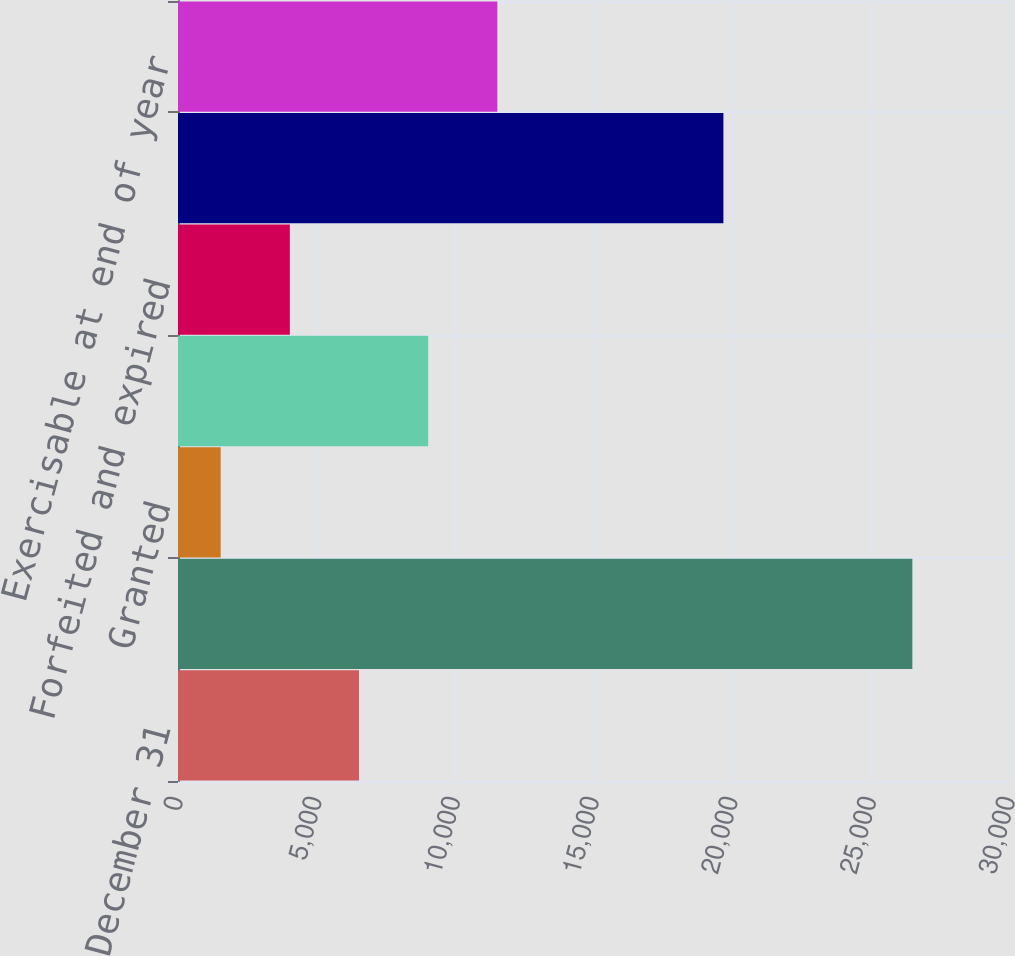Convert chart. <chart><loc_0><loc_0><loc_500><loc_500><bar_chart><fcel>Years ended December 31<fcel>Beginning outstanding<fcel>Granted<fcel>Exercised<fcel>Forfeited and expired<fcel>Outstanding at end of year<fcel>Exercisable at end of year<nl><fcel>6527<fcel>26479<fcel>1539<fcel>9021<fcel>4033<fcel>19666<fcel>11515<nl></chart> 